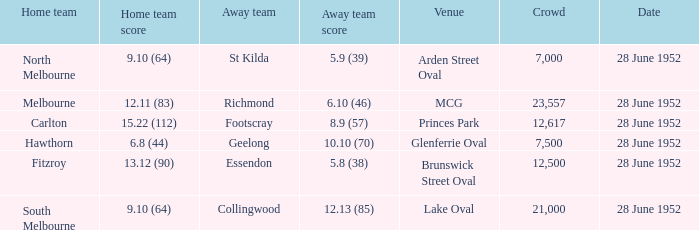What is the away team when north melbourne is at home? St Kilda. 